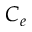Convert formula to latex. <formula><loc_0><loc_0><loc_500><loc_500>C _ { e }</formula> 